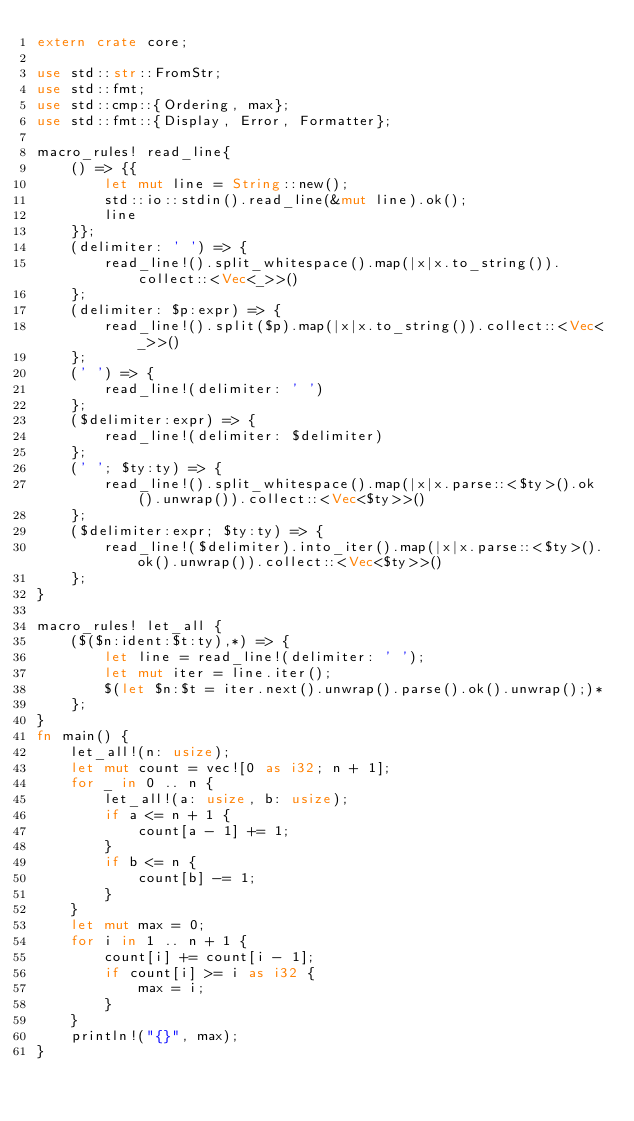<code> <loc_0><loc_0><loc_500><loc_500><_Rust_>extern crate core;

use std::str::FromStr;
use std::fmt;
use std::cmp::{Ordering, max};
use std::fmt::{Display, Error, Formatter};

macro_rules! read_line{
    () => {{
        let mut line = String::new();
        std::io::stdin().read_line(&mut line).ok();
        line
    }};
    (delimiter: ' ') => {
        read_line!().split_whitespace().map(|x|x.to_string()).collect::<Vec<_>>()
    };
    (delimiter: $p:expr) => {
        read_line!().split($p).map(|x|x.to_string()).collect::<Vec<_>>()
    };
    (' ') => {
        read_line!(delimiter: ' ')
    };
    ($delimiter:expr) => {
        read_line!(delimiter: $delimiter)
    };
    (' '; $ty:ty) => {
        read_line!().split_whitespace().map(|x|x.parse::<$ty>().ok().unwrap()).collect::<Vec<$ty>>()
    };
    ($delimiter:expr; $ty:ty) => {
        read_line!($delimiter).into_iter().map(|x|x.parse::<$ty>().ok().unwrap()).collect::<Vec<$ty>>()
    };
}

macro_rules! let_all {
    ($($n:ident:$t:ty),*) => {
        let line = read_line!(delimiter: ' ');
        let mut iter = line.iter();
        $(let $n:$t = iter.next().unwrap().parse().ok().unwrap();)*
    };
}
fn main() {
    let_all!(n: usize);
    let mut count = vec![0 as i32; n + 1];
    for _ in 0 .. n {
        let_all!(a: usize, b: usize);
        if a <= n + 1 {
            count[a - 1] += 1;
        }
        if b <= n {
            count[b] -= 1;
        }
    }
    let mut max = 0;
    for i in 1 .. n + 1 {
        count[i] += count[i - 1];
        if count[i] >= i as i32 {
            max = i;
        }
    }
    println!("{}", max);
}

</code> 